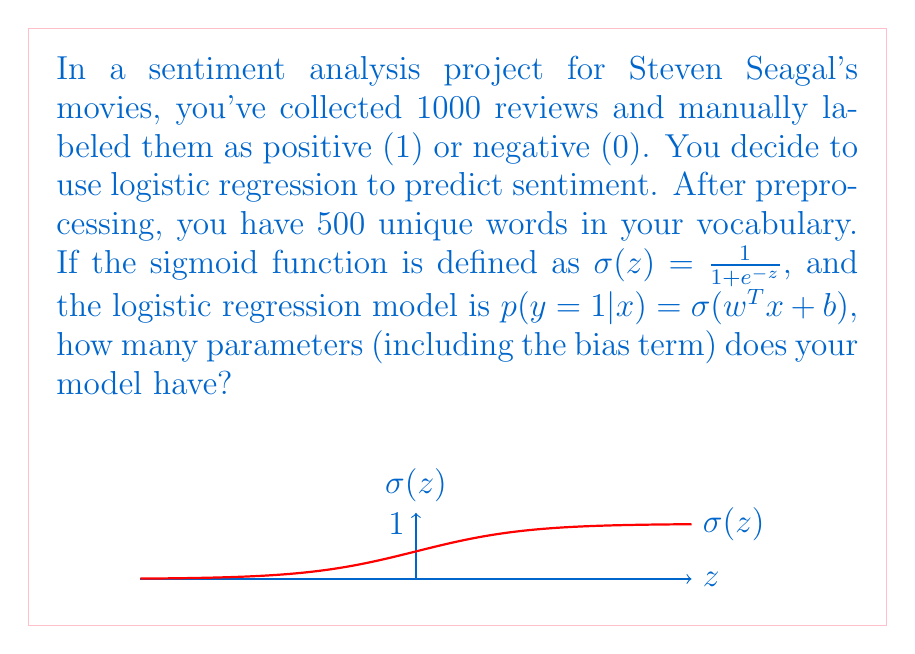Can you solve this math problem? Let's break this down step-by-step:

1) In logistic regression, we have one parameter (weight) for each feature in our input vector.

2) In this case, our features are the words in our vocabulary. We have 500 unique words, so we need 500 weights.

3) The formula for logistic regression also includes a bias term $b$. This is essentially like having an additional feature that's always 1, allowing the model to shift the decision boundary.

4) Therefore, the total number of parameters is:
   $$ \text{Number of parameters} = \text{Number of features} + \text{Bias term} $$
   $$ = 500 + 1 = 501 $$

5) Each of these 501 parameters needs to be learned during the training process to create a model that can effectively predict the sentiment of Steven Seagal movie reviews.

This model will output a probability between 0 and 1 (thanks to the sigmoid function), which can be interpreted as the likelihood of a review being positive. A threshold (typically 0.5) can then be used to classify the review as positive or negative.
Answer: 501 